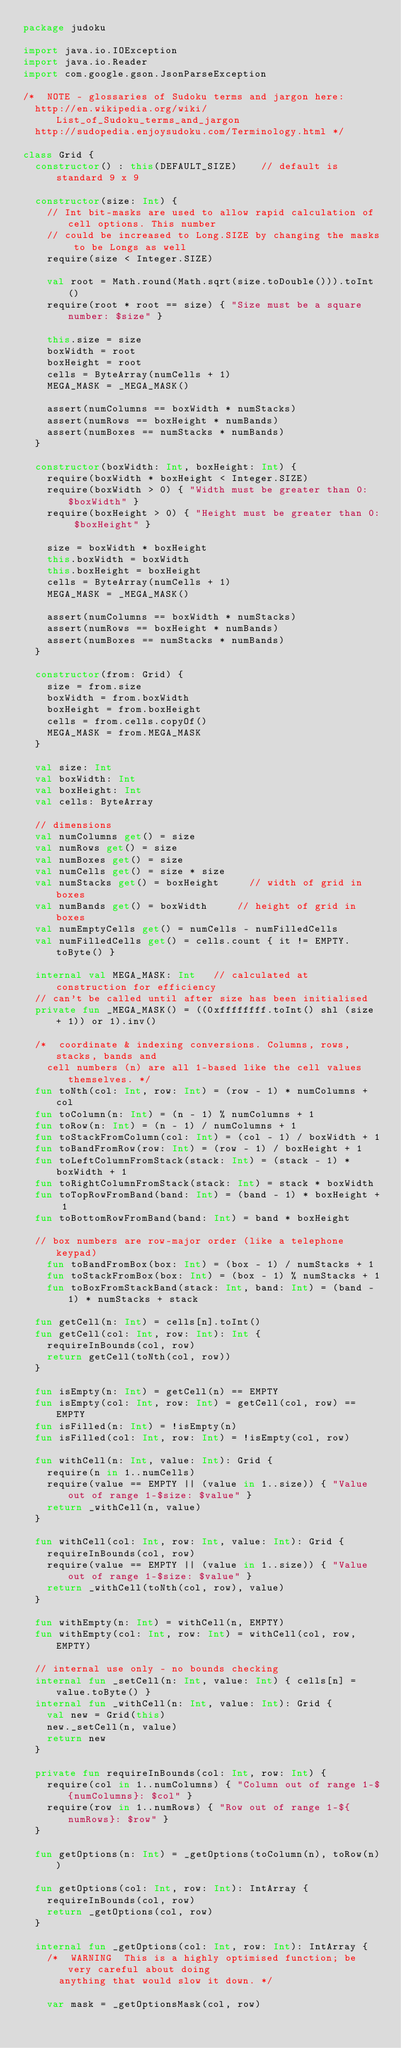Convert code to text. <code><loc_0><loc_0><loc_500><loc_500><_Kotlin_>package judoku

import java.io.IOException
import java.io.Reader
import com.google.gson.JsonParseException

/*	NOTE - glossaries of Sudoku terms and jargon here:
	http://en.wikipedia.org/wiki/List_of_Sudoku_terms_and_jargon
	http://sudopedia.enjoysudoku.com/Terminology.html */

class Grid {
	constructor() : this(DEFAULT_SIZE)		// default is standard 9 x 9

	constructor(size: Int) {
		// Int bit-masks are used to allow rapid calculation of cell options. This number
		// could be increased to Long.SIZE by changing the masks to be Longs as well
		require(size < Integer.SIZE)

		val root = Math.round(Math.sqrt(size.toDouble())).toInt()
		require(root * root == size) { "Size must be a square number: $size" }

		this.size = size
		boxWidth = root
		boxHeight = root
		cells = ByteArray(numCells + 1)
		MEGA_MASK = _MEGA_MASK()

		assert(numColumns == boxWidth * numStacks)
		assert(numRows == boxHeight * numBands)
		assert(numBoxes == numStacks * numBands)
	}

	constructor(boxWidth: Int, boxHeight: Int) {
		require(boxWidth * boxHeight < Integer.SIZE)
		require(boxWidth > 0) { "Width must be greater than 0: $boxWidth" }
		require(boxHeight > 0) { "Height must be greater than 0: $boxHeight" }

		size = boxWidth * boxHeight
		this.boxWidth = boxWidth
		this.boxHeight = boxHeight
		cells = ByteArray(numCells + 1)
		MEGA_MASK = _MEGA_MASK()

		assert(numColumns == boxWidth * numStacks)
		assert(numRows == boxHeight * numBands)
		assert(numBoxes == numStacks * numBands)
	}

	constructor(from: Grid) {
		size = from.size
		boxWidth = from.boxWidth
		boxHeight = from.boxHeight
		cells = from.cells.copyOf()
		MEGA_MASK = from.MEGA_MASK
	}

	val size: Int
	val boxWidth: Int
	val boxHeight: Int
	val cells: ByteArray

	// dimensions
	val numColumns get() = size
	val numRows get() = size
	val numBoxes get() = size
	val numCells get() = size * size
	val numStacks get() = boxHeight			// width of grid in boxes
	val numBands get() = boxWidth			// height of grid in boxes
	val numEmptyCells get() = numCells - numFilledCells
	val numFilledCells get() = cells.count { it != EMPTY.toByte() }

	internal val MEGA_MASK: Int		// calculated at construction for efficiency
	// can't be called until after size has been initialised
	private fun _MEGA_MASK() = ((0xffffffff.toInt() shl (size + 1)) or 1).inv()

	/*	coordinate & indexing conversions. Columns, rows, stacks, bands and
		cell numbers (n) are all 1-based like the cell values themselves. */
	fun toNth(col: Int, row: Int) = (row - 1) * numColumns + col
	fun toColumn(n: Int) = (n - 1) % numColumns + 1
	fun toRow(n: Int) = (n - 1) / numColumns + 1
	fun toStackFromColumn(col: Int) = (col - 1) / boxWidth + 1
	fun toBandFromRow(row: Int) = (row - 1) / boxHeight + 1
	fun toLeftColumnFromStack(stack: Int) = (stack - 1) * boxWidth + 1
	fun toRightColumnFromStack(stack: Int) = stack * boxWidth
	fun toTopRowFromBand(band: Int) = (band - 1) * boxHeight + 1
	fun toBottomRowFromBand(band: Int) = band * boxHeight

	// box numbers are row-major order (like a telephone keypad)
    fun toBandFromBox(box: Int) = (box - 1) / numStacks + 1
    fun toStackFromBox(box: Int) = (box - 1) % numStacks + 1
    fun toBoxFromStackBand(stack: Int, band: Int) = (band - 1) * numStacks + stack

	fun getCell(n: Int) = cells[n].toInt()
	fun getCell(col: Int, row: Int): Int {
		requireInBounds(col, row)
		return getCell(toNth(col, row))
	}

	fun isEmpty(n: Int) = getCell(n) == EMPTY
	fun isEmpty(col: Int, row: Int) = getCell(col, row) == EMPTY
	fun isFilled(n: Int) = !isEmpty(n)
	fun isFilled(col: Int, row: Int) = !isEmpty(col, row)

	fun withCell(n: Int, value: Int): Grid {
		require(n in 1..numCells)
		require(value == EMPTY || (value in 1..size)) { "Value out of range 1-$size: $value" }
		return _withCell(n, value)
	}

	fun withCell(col: Int, row: Int, value: Int): Grid {
		requireInBounds(col, row)
		require(value == EMPTY || (value in 1..size)) { "Value out of range 1-$size: $value" }
		return _withCell(toNth(col, row), value)
	}

	fun withEmpty(n: Int) = withCell(n, EMPTY)
	fun withEmpty(col: Int, row: Int) = withCell(col, row, EMPTY)

	// internal use only - no bounds checking
	internal fun _setCell(n: Int, value: Int) { cells[n] = value.toByte() }
	internal fun _withCell(n: Int, value: Int): Grid {
		val new = Grid(this)
		new._setCell(n, value)
		return new
	}

	private fun requireInBounds(col: Int, row: Int) {
		require(col in 1..numColumns) { "Column out of range 1-${numColumns}: $col" }
		require(row in 1..numRows) { "Row out of range 1-${numRows}: $row" }
	}

	fun getOptions(n: Int) = _getOptions(toColumn(n), toRow(n))

	fun getOptions(col: Int, row: Int): IntArray {
		requireInBounds(col, row)
		return _getOptions(col, row)
	}

	internal fun _getOptions(col: Int, row: Int): IntArray {
		/*	WARNING  This is a highly optimised function; be very careful about doing
		 	anything that would slow it down. */

		var mask = _getOptionsMask(col, row)</code> 